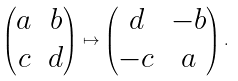<formula> <loc_0><loc_0><loc_500><loc_500>\begin{pmatrix} a & b \\ c & d \end{pmatrix} \mapsto \begin{pmatrix} d & - b \\ - c & a \end{pmatrix} .</formula> 